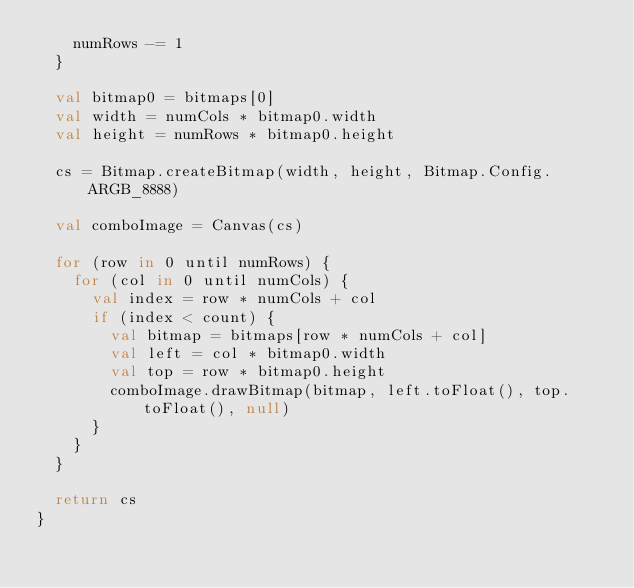Convert code to text. <code><loc_0><loc_0><loc_500><loc_500><_Kotlin_>    numRows -= 1
  }

  val bitmap0 = bitmaps[0]
  val width = numCols * bitmap0.width
  val height = numRows * bitmap0.height

  cs = Bitmap.createBitmap(width, height, Bitmap.Config.ARGB_8888)

  val comboImage = Canvas(cs)

  for (row in 0 until numRows) {
    for (col in 0 until numCols) {
      val index = row * numCols + col
      if (index < count) {
        val bitmap = bitmaps[row * numCols + col]
        val left = col * bitmap0.width
        val top = row * bitmap0.height
        comboImage.drawBitmap(bitmap, left.toFloat(), top.toFloat(), null)
      }
    }
  }

  return cs
}</code> 